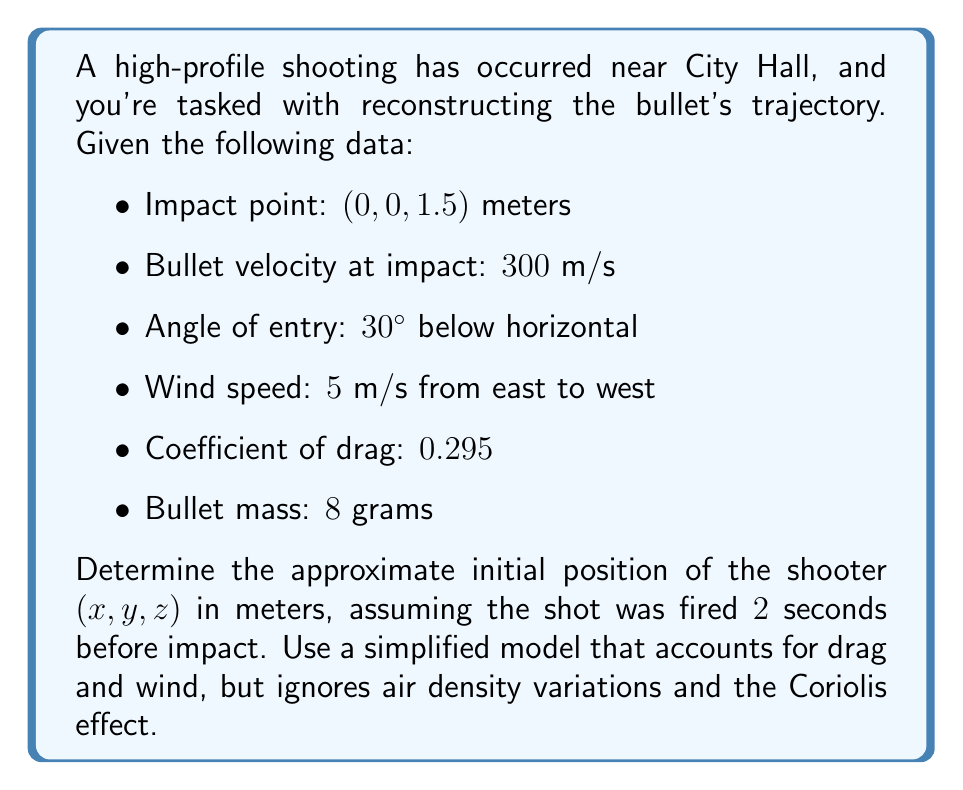Help me with this question. To solve this inverse problem, we'll work backwards from the impact point using the given information. We'll use a simplified model of bullet motion that includes drag and wind effects.

Step 1: Calculate the bullet's velocity components at impact.
$$v_x = 300 \cos(30°) \cos(0°) = 259.81 \text{ m/s}$$
$$v_y = 300 \cos(30°) \sin(0°) = 0 \text{ m/s}$$
$$v_z = -300 \sin(30°) = -150 \text{ m/s}$$

Step 2: Calculate the drag force at impact.
$$F_d = \frac{1}{2} \rho v^2 C_d A$$
Where $\rho$ is air density (approx. 1.225 kg/m³), $v$ is velocity, $C_d$ is the drag coefficient, and $A$ is the bullet's cross-sectional area (assumed to be $5 \times 10^{-5} \text{ m}^2$).

$$F_d = \frac{1}{2} (1.225)(300^2)(0.295)(5 \times 10^{-5}) = 0.8138 \text{ N}$$

Step 3: Calculate the acceleration due to drag.
$$a_d = \frac{F_d}{m} = \frac{0.8138}{0.008} = 101.73 \text{ m/s}^2$$

Step 4: Calculate the average acceleration over the 2-second flight time, assuming linear deceleration.
$$\bar{a} = \frac{a_d}{2} = 50.865 \text{ m/s}^2$$

Step 5: Use kinematics equations to find the initial velocity components, accounting for drag and wind.
$$v_{x0} = v_x + \bar{a}t + w_x = 259.81 + (50.865 \times 2) - 5 = 356.54 \text{ m/s}$$
$$v_{y0} = v_y = 0 \text{ m/s}$$
$$v_{z0} = v_z + gt = -150 + (9.8 \times 2) = -130.4 \text{ m/s}$$

Where $w_x$ is the wind speed and $g$ is the acceleration due to gravity.

Step 6: Calculate the initial position using the average velocity over the flight time.
$$x_0 = -(\frac{v_x + v_{x0}}{2})t = -(\frac{259.81 + 356.54}{2})(2) = -616.35 \text{ m}$$
$$y_0 = -(\frac{v_y + v_{y0}}{2})t = 0 \text{ m}$$
$$z_0 = 1.5 - (\frac{v_z + v_{z0}}{2})t = 1.5 - (\frac{-150 + (-130.4)}{2})(2) = 281.9 \text{ m}$$

Therefore, the approximate initial position of the shooter is (-616.35, 0, 281.9) meters.
Answer: (-616.35, 0, 281.9) meters 